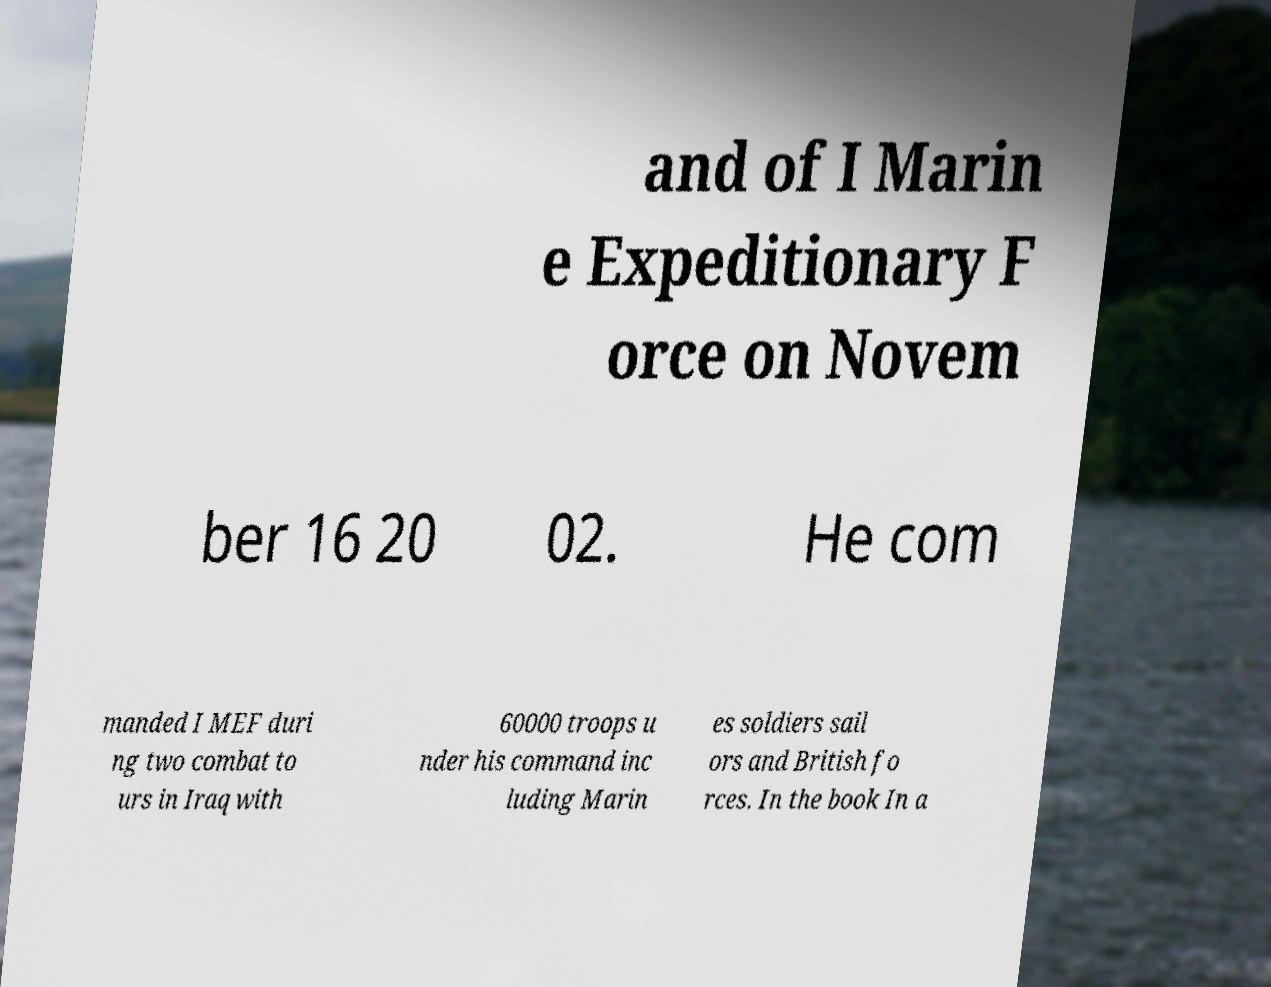I need the written content from this picture converted into text. Can you do that? and of I Marin e Expeditionary F orce on Novem ber 16 20 02. He com manded I MEF duri ng two combat to urs in Iraq with 60000 troops u nder his command inc luding Marin es soldiers sail ors and British fo rces. In the book In a 